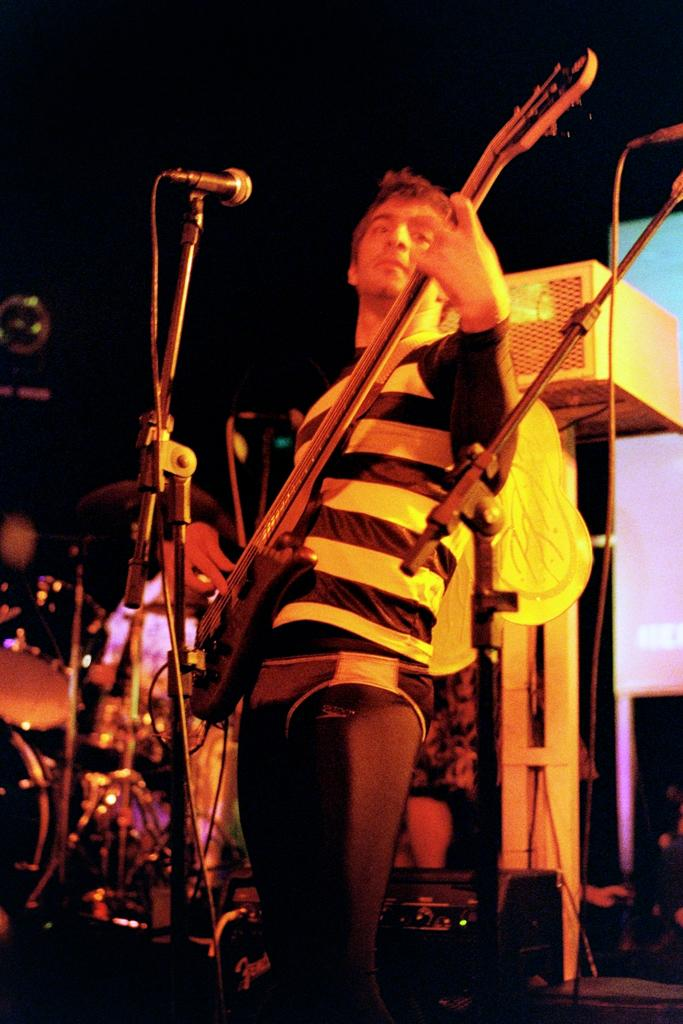What is the main subject of the image? The main subject of the image is a man. What is the man doing in the image? The man is standing in the image. What object is the man holding in his hands? The man is holding a guitar in his hands. What other objects can be seen in the image? There is a microphone and a stand in the image. How many waves can be seen crashing on the shore in the image? There are no waves or shore visible in the image; it features a man holding a guitar and standing near a microphone and a stand. 